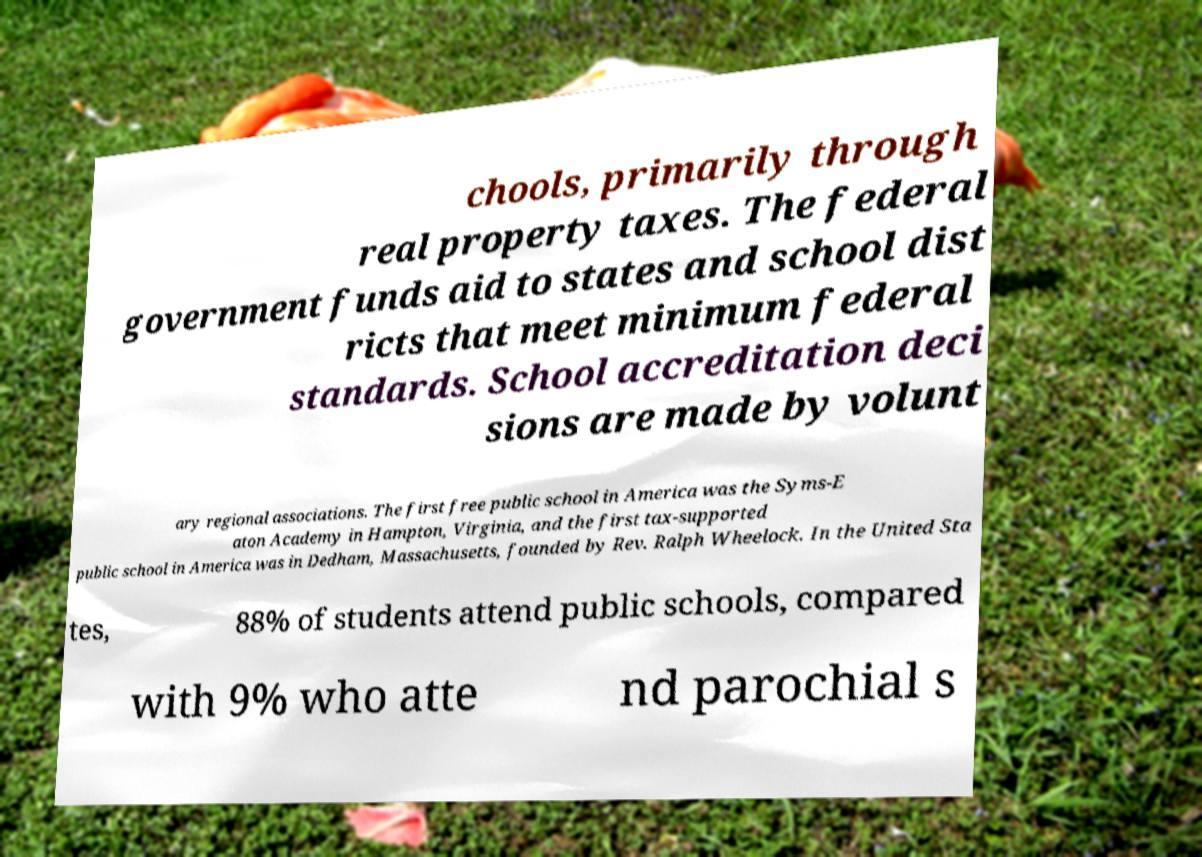There's text embedded in this image that I need extracted. Can you transcribe it verbatim? chools, primarily through real property taxes. The federal government funds aid to states and school dist ricts that meet minimum federal standards. School accreditation deci sions are made by volunt ary regional associations. The first free public school in America was the Syms-E aton Academy in Hampton, Virginia, and the first tax-supported public school in America was in Dedham, Massachusetts, founded by Rev. Ralph Wheelock. In the United Sta tes, 88% of students attend public schools, compared with 9% who atte nd parochial s 